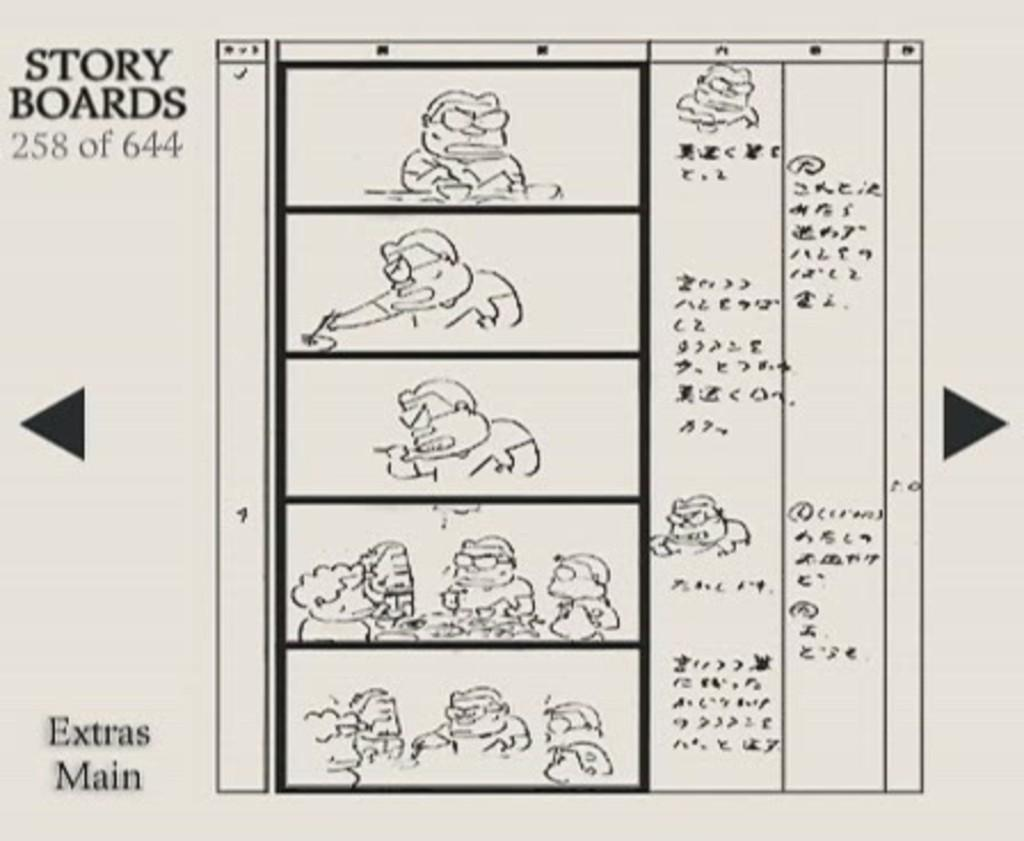What is the main subject in the center of the image? There is a poster in the center of the image. What type of characters are featured on the poster? The poster contains cartoon characters. Is there any text on the poster? Yes, there is text on the poster. What type of development can be seen taking place in the image? There is no development taking place in the image; it features a poster with cartoon characters and text. What causes the characters on the poster to feel shame? There is no indication of shame or any emotional state in the image; it simply shows a poster with cartoon characters and text. 